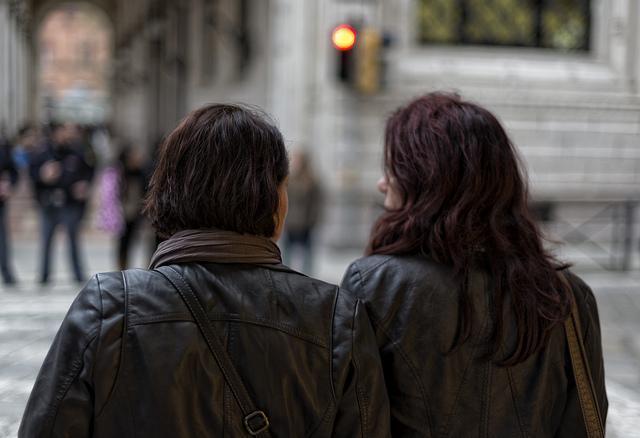How many people are there?
Give a very brief answer. 5. How many handbags are in the photo?
Give a very brief answer. 2. How many laptops are there?
Give a very brief answer. 0. 